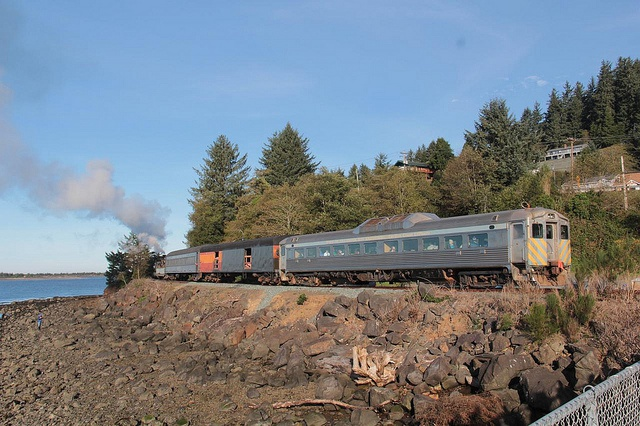Describe the objects in this image and their specific colors. I can see train in gray, black, and darkgray tones, people in darkgray, gray, and blue tones, people in darkgray, gray, and blue tones, people in darkgray, gray, teal, and tan tones, and people in gray and darkgray tones in this image. 